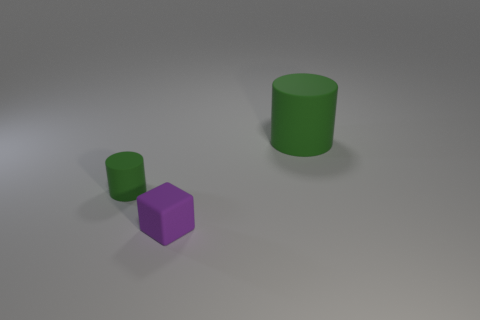Add 3 green rubber objects. How many objects exist? 6 Subtract all cylinders. How many objects are left? 1 Add 1 green matte objects. How many green matte objects are left? 3 Add 2 purple rubber blocks. How many purple rubber blocks exist? 3 Subtract 0 gray balls. How many objects are left? 3 Subtract all tiny yellow metal blocks. Subtract all large cylinders. How many objects are left? 2 